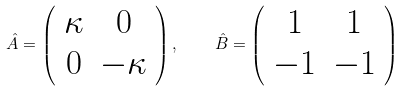<formula> <loc_0><loc_0><loc_500><loc_500>\hat { A } = \left ( \begin{array} { c c } \kappa & 0 \\ 0 & - \kappa \end{array} \right ) , \quad \hat { B } = \left ( \begin{array} { c c } 1 & 1 \\ - 1 & - 1 \end{array} \right )</formula> 